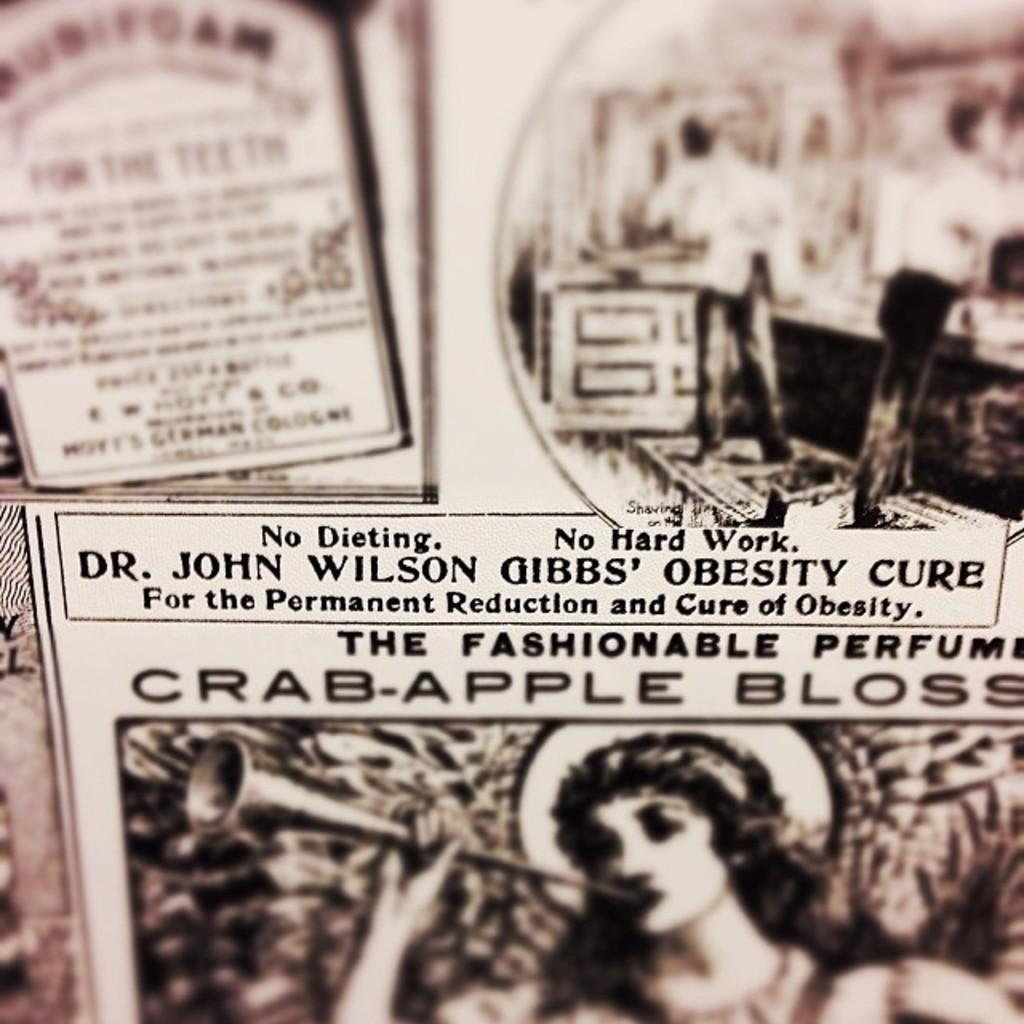What is present in the image that contains both images and text? There is a poster in the image that contains images and text. Can you describe the images on the poster? Unfortunately, the specific images on the poster cannot be described without more information. What type of information might be conveyed through the text on the poster? The text on the poster could convey various types of information, such as advertising, instructions, or a message. How many marbles are rolling across the poster in the image? There are no marbles present in the image, and therefore no marbles can be seen rolling across the poster. 